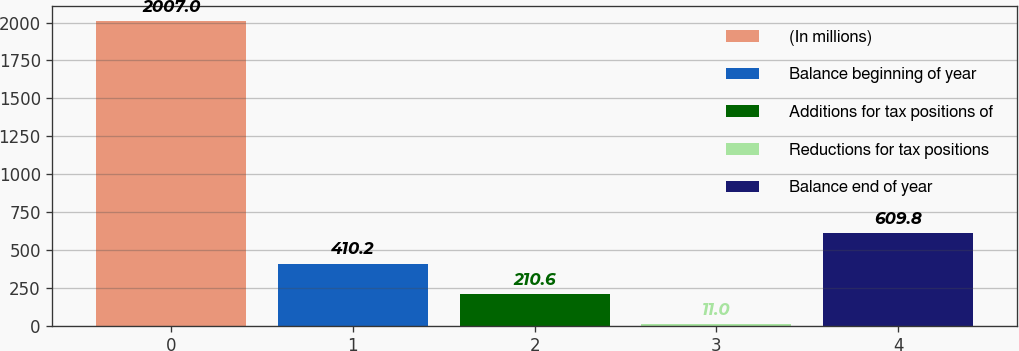Convert chart. <chart><loc_0><loc_0><loc_500><loc_500><bar_chart><fcel>(In millions)<fcel>Balance beginning of year<fcel>Additions for tax positions of<fcel>Reductions for tax positions<fcel>Balance end of year<nl><fcel>2007<fcel>410.2<fcel>210.6<fcel>11<fcel>609.8<nl></chart> 